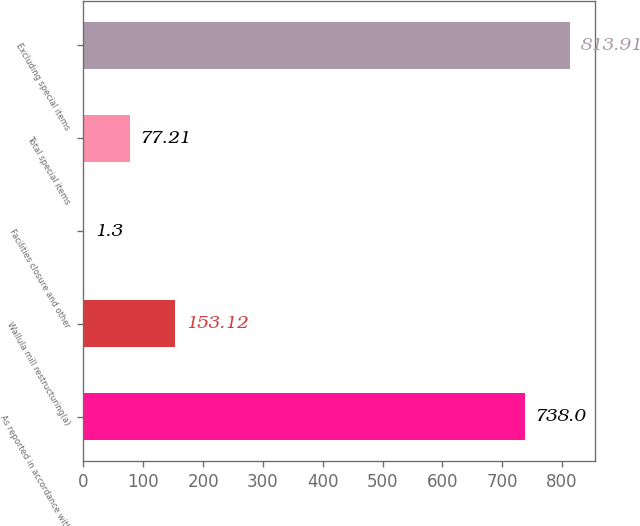<chart> <loc_0><loc_0><loc_500><loc_500><bar_chart><fcel>As reported in accordance with<fcel>Wallula mill restructuring(a)<fcel>Facilities closure and other<fcel>Total special items<fcel>Excluding special items<nl><fcel>738<fcel>153.12<fcel>1.3<fcel>77.21<fcel>813.91<nl></chart> 